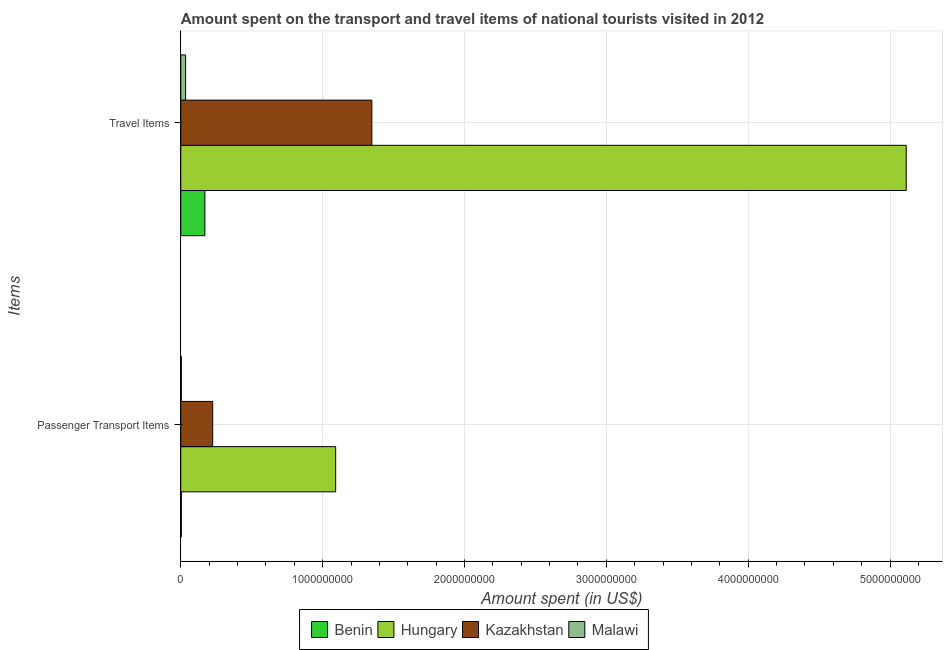How many different coloured bars are there?
Provide a short and direct response. 4. How many groups of bars are there?
Make the answer very short. 2. Are the number of bars per tick equal to the number of legend labels?
Keep it short and to the point. Yes. How many bars are there on the 2nd tick from the top?
Offer a terse response. 4. What is the label of the 2nd group of bars from the top?
Give a very brief answer. Passenger Transport Items. What is the amount spent in travel items in Kazakhstan?
Your answer should be compact. 1.35e+09. Across all countries, what is the maximum amount spent in travel items?
Offer a very short reply. 5.11e+09. Across all countries, what is the minimum amount spent on passenger transport items?
Ensure brevity in your answer.  4.00e+06. In which country was the amount spent on passenger transport items maximum?
Your response must be concise. Hungary. In which country was the amount spent in travel items minimum?
Your answer should be very brief. Malawi. What is the total amount spent in travel items in the graph?
Keep it short and to the point. 6.66e+09. What is the difference between the amount spent in travel items in Malawi and that in Hungary?
Ensure brevity in your answer.  -5.08e+09. What is the difference between the amount spent on passenger transport items in Benin and the amount spent in travel items in Hungary?
Your answer should be compact. -5.11e+09. What is the average amount spent on passenger transport items per country?
Your response must be concise. 3.31e+08. What is the difference between the amount spent on passenger transport items and amount spent in travel items in Kazakhstan?
Make the answer very short. -1.12e+09. In how many countries, is the amount spent in travel items greater than 4800000000 US$?
Ensure brevity in your answer.  1. In how many countries, is the amount spent on passenger transport items greater than the average amount spent on passenger transport items taken over all countries?
Give a very brief answer. 1. What does the 4th bar from the top in Passenger Transport Items represents?
Your answer should be very brief. Benin. What does the 4th bar from the bottom in Travel Items represents?
Provide a short and direct response. Malawi. What is the difference between two consecutive major ticks on the X-axis?
Keep it short and to the point. 1.00e+09. Does the graph contain any zero values?
Your answer should be very brief. No. Does the graph contain grids?
Your response must be concise. Yes. Where does the legend appear in the graph?
Give a very brief answer. Bottom center. What is the title of the graph?
Offer a terse response. Amount spent on the transport and travel items of national tourists visited in 2012. Does "Malta" appear as one of the legend labels in the graph?
Your answer should be compact. No. What is the label or title of the X-axis?
Your answer should be compact. Amount spent (in US$). What is the label or title of the Y-axis?
Provide a succinct answer. Items. What is the Amount spent (in US$) of Benin in Passenger Transport Items?
Ensure brevity in your answer.  4.00e+06. What is the Amount spent (in US$) in Hungary in Passenger Transport Items?
Offer a very short reply. 1.09e+09. What is the Amount spent (in US$) of Kazakhstan in Passenger Transport Items?
Make the answer very short. 2.25e+08. What is the Amount spent (in US$) of Benin in Travel Items?
Make the answer very short. 1.70e+08. What is the Amount spent (in US$) of Hungary in Travel Items?
Your answer should be very brief. 5.11e+09. What is the Amount spent (in US$) of Kazakhstan in Travel Items?
Provide a short and direct response. 1.35e+09. What is the Amount spent (in US$) of Malawi in Travel Items?
Offer a terse response. 3.40e+07. Across all Items, what is the maximum Amount spent (in US$) of Benin?
Provide a short and direct response. 1.70e+08. Across all Items, what is the maximum Amount spent (in US$) in Hungary?
Give a very brief answer. 5.11e+09. Across all Items, what is the maximum Amount spent (in US$) in Kazakhstan?
Provide a succinct answer. 1.35e+09. Across all Items, what is the maximum Amount spent (in US$) of Malawi?
Provide a succinct answer. 3.40e+07. Across all Items, what is the minimum Amount spent (in US$) of Benin?
Make the answer very short. 4.00e+06. Across all Items, what is the minimum Amount spent (in US$) in Hungary?
Your response must be concise. 1.09e+09. Across all Items, what is the minimum Amount spent (in US$) in Kazakhstan?
Your answer should be very brief. 2.25e+08. Across all Items, what is the minimum Amount spent (in US$) of Malawi?
Your response must be concise. 4.00e+06. What is the total Amount spent (in US$) of Benin in the graph?
Your answer should be compact. 1.74e+08. What is the total Amount spent (in US$) of Hungary in the graph?
Your answer should be compact. 6.21e+09. What is the total Amount spent (in US$) of Kazakhstan in the graph?
Your answer should be very brief. 1.57e+09. What is the total Amount spent (in US$) of Malawi in the graph?
Provide a short and direct response. 3.80e+07. What is the difference between the Amount spent (in US$) of Benin in Passenger Transport Items and that in Travel Items?
Your response must be concise. -1.66e+08. What is the difference between the Amount spent (in US$) in Hungary in Passenger Transport Items and that in Travel Items?
Provide a short and direct response. -4.02e+09. What is the difference between the Amount spent (in US$) in Kazakhstan in Passenger Transport Items and that in Travel Items?
Offer a very short reply. -1.12e+09. What is the difference between the Amount spent (in US$) in Malawi in Passenger Transport Items and that in Travel Items?
Your response must be concise. -3.00e+07. What is the difference between the Amount spent (in US$) of Benin in Passenger Transport Items and the Amount spent (in US$) of Hungary in Travel Items?
Your answer should be compact. -5.11e+09. What is the difference between the Amount spent (in US$) in Benin in Passenger Transport Items and the Amount spent (in US$) in Kazakhstan in Travel Items?
Your response must be concise. -1.34e+09. What is the difference between the Amount spent (in US$) in Benin in Passenger Transport Items and the Amount spent (in US$) in Malawi in Travel Items?
Offer a very short reply. -3.00e+07. What is the difference between the Amount spent (in US$) in Hungary in Passenger Transport Items and the Amount spent (in US$) in Kazakhstan in Travel Items?
Your response must be concise. -2.55e+08. What is the difference between the Amount spent (in US$) in Hungary in Passenger Transport Items and the Amount spent (in US$) in Malawi in Travel Items?
Offer a very short reply. 1.06e+09. What is the difference between the Amount spent (in US$) in Kazakhstan in Passenger Transport Items and the Amount spent (in US$) in Malawi in Travel Items?
Offer a terse response. 1.91e+08. What is the average Amount spent (in US$) of Benin per Items?
Your answer should be very brief. 8.70e+07. What is the average Amount spent (in US$) of Hungary per Items?
Your response must be concise. 3.10e+09. What is the average Amount spent (in US$) of Kazakhstan per Items?
Offer a very short reply. 7.86e+08. What is the average Amount spent (in US$) in Malawi per Items?
Your answer should be compact. 1.90e+07. What is the difference between the Amount spent (in US$) of Benin and Amount spent (in US$) of Hungary in Passenger Transport Items?
Offer a very short reply. -1.09e+09. What is the difference between the Amount spent (in US$) of Benin and Amount spent (in US$) of Kazakhstan in Passenger Transport Items?
Provide a short and direct response. -2.21e+08. What is the difference between the Amount spent (in US$) in Benin and Amount spent (in US$) in Malawi in Passenger Transport Items?
Keep it short and to the point. 0. What is the difference between the Amount spent (in US$) of Hungary and Amount spent (in US$) of Kazakhstan in Passenger Transport Items?
Give a very brief answer. 8.67e+08. What is the difference between the Amount spent (in US$) of Hungary and Amount spent (in US$) of Malawi in Passenger Transport Items?
Your answer should be compact. 1.09e+09. What is the difference between the Amount spent (in US$) in Kazakhstan and Amount spent (in US$) in Malawi in Passenger Transport Items?
Offer a terse response. 2.21e+08. What is the difference between the Amount spent (in US$) of Benin and Amount spent (in US$) of Hungary in Travel Items?
Offer a very short reply. -4.94e+09. What is the difference between the Amount spent (in US$) in Benin and Amount spent (in US$) in Kazakhstan in Travel Items?
Provide a short and direct response. -1.18e+09. What is the difference between the Amount spent (in US$) of Benin and Amount spent (in US$) of Malawi in Travel Items?
Provide a short and direct response. 1.36e+08. What is the difference between the Amount spent (in US$) of Hungary and Amount spent (in US$) of Kazakhstan in Travel Items?
Keep it short and to the point. 3.77e+09. What is the difference between the Amount spent (in US$) of Hungary and Amount spent (in US$) of Malawi in Travel Items?
Give a very brief answer. 5.08e+09. What is the difference between the Amount spent (in US$) in Kazakhstan and Amount spent (in US$) in Malawi in Travel Items?
Make the answer very short. 1.31e+09. What is the ratio of the Amount spent (in US$) of Benin in Passenger Transport Items to that in Travel Items?
Your answer should be very brief. 0.02. What is the ratio of the Amount spent (in US$) of Hungary in Passenger Transport Items to that in Travel Items?
Keep it short and to the point. 0.21. What is the ratio of the Amount spent (in US$) in Kazakhstan in Passenger Transport Items to that in Travel Items?
Your answer should be compact. 0.17. What is the ratio of the Amount spent (in US$) in Malawi in Passenger Transport Items to that in Travel Items?
Give a very brief answer. 0.12. What is the difference between the highest and the second highest Amount spent (in US$) of Benin?
Offer a very short reply. 1.66e+08. What is the difference between the highest and the second highest Amount spent (in US$) of Hungary?
Give a very brief answer. 4.02e+09. What is the difference between the highest and the second highest Amount spent (in US$) of Kazakhstan?
Keep it short and to the point. 1.12e+09. What is the difference between the highest and the second highest Amount spent (in US$) of Malawi?
Offer a very short reply. 3.00e+07. What is the difference between the highest and the lowest Amount spent (in US$) in Benin?
Your answer should be very brief. 1.66e+08. What is the difference between the highest and the lowest Amount spent (in US$) of Hungary?
Make the answer very short. 4.02e+09. What is the difference between the highest and the lowest Amount spent (in US$) in Kazakhstan?
Ensure brevity in your answer.  1.12e+09. What is the difference between the highest and the lowest Amount spent (in US$) of Malawi?
Make the answer very short. 3.00e+07. 